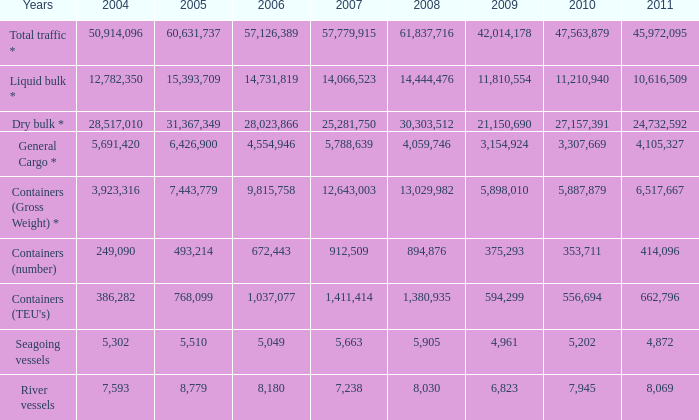What was the total in 2009 for years of river vessels when 2008 was more than 8,030 and 2007 was more than 1,411,414? 0.0. 